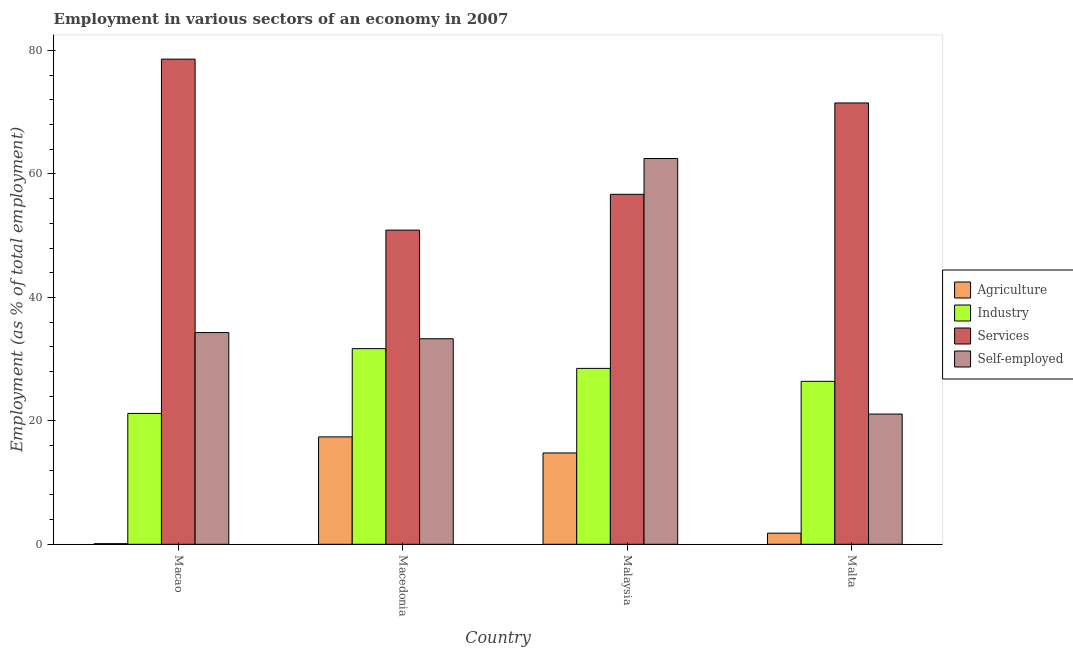How many groups of bars are there?
Offer a terse response. 4. How many bars are there on the 4th tick from the right?
Ensure brevity in your answer.  4. What is the label of the 2nd group of bars from the left?
Your answer should be very brief. Macedonia. In how many cases, is the number of bars for a given country not equal to the number of legend labels?
Your response must be concise. 0. What is the percentage of self employed workers in Malta?
Ensure brevity in your answer.  21.1. Across all countries, what is the maximum percentage of self employed workers?
Your response must be concise. 62.5. Across all countries, what is the minimum percentage of workers in services?
Provide a succinct answer. 50.9. In which country was the percentage of workers in services maximum?
Give a very brief answer. Macao. In which country was the percentage of workers in services minimum?
Ensure brevity in your answer.  Macedonia. What is the total percentage of workers in agriculture in the graph?
Provide a succinct answer. 34.1. What is the difference between the percentage of self employed workers in Macedonia and that in Malta?
Your answer should be very brief. 12.2. What is the difference between the percentage of workers in services in Malaysia and the percentage of workers in agriculture in Macedonia?
Provide a short and direct response. 39.3. What is the average percentage of workers in agriculture per country?
Your answer should be very brief. 8.52. What is the difference between the percentage of workers in agriculture and percentage of workers in services in Malaysia?
Offer a very short reply. -41.9. What is the ratio of the percentage of self employed workers in Macao to that in Macedonia?
Give a very brief answer. 1.03. Is the percentage of self employed workers in Macao less than that in Macedonia?
Offer a terse response. No. Is the difference between the percentage of workers in agriculture in Macao and Malaysia greater than the difference between the percentage of self employed workers in Macao and Malaysia?
Provide a succinct answer. Yes. What is the difference between the highest and the second highest percentage of workers in industry?
Give a very brief answer. 3.2. What is the difference between the highest and the lowest percentage of workers in services?
Give a very brief answer. 27.7. In how many countries, is the percentage of self employed workers greater than the average percentage of self employed workers taken over all countries?
Your answer should be compact. 1. Is it the case that in every country, the sum of the percentage of self employed workers and percentage of workers in agriculture is greater than the sum of percentage of workers in services and percentage of workers in industry?
Give a very brief answer. No. What does the 4th bar from the left in Malta represents?
Your response must be concise. Self-employed. What does the 2nd bar from the right in Macao represents?
Give a very brief answer. Services. Are all the bars in the graph horizontal?
Your response must be concise. No. How many countries are there in the graph?
Make the answer very short. 4. Are the values on the major ticks of Y-axis written in scientific E-notation?
Provide a short and direct response. No. Does the graph contain grids?
Your answer should be compact. No. How are the legend labels stacked?
Your response must be concise. Vertical. What is the title of the graph?
Ensure brevity in your answer.  Employment in various sectors of an economy in 2007. What is the label or title of the Y-axis?
Offer a terse response. Employment (as % of total employment). What is the Employment (as % of total employment) in Agriculture in Macao?
Offer a terse response. 0.1. What is the Employment (as % of total employment) of Industry in Macao?
Give a very brief answer. 21.2. What is the Employment (as % of total employment) of Services in Macao?
Provide a succinct answer. 78.6. What is the Employment (as % of total employment) in Self-employed in Macao?
Make the answer very short. 34.3. What is the Employment (as % of total employment) in Agriculture in Macedonia?
Give a very brief answer. 17.4. What is the Employment (as % of total employment) in Industry in Macedonia?
Keep it short and to the point. 31.7. What is the Employment (as % of total employment) in Services in Macedonia?
Your answer should be very brief. 50.9. What is the Employment (as % of total employment) of Self-employed in Macedonia?
Provide a succinct answer. 33.3. What is the Employment (as % of total employment) in Agriculture in Malaysia?
Provide a succinct answer. 14.8. What is the Employment (as % of total employment) of Industry in Malaysia?
Offer a very short reply. 28.5. What is the Employment (as % of total employment) of Services in Malaysia?
Keep it short and to the point. 56.7. What is the Employment (as % of total employment) of Self-employed in Malaysia?
Offer a very short reply. 62.5. What is the Employment (as % of total employment) of Agriculture in Malta?
Your answer should be very brief. 1.8. What is the Employment (as % of total employment) in Industry in Malta?
Make the answer very short. 26.4. What is the Employment (as % of total employment) in Services in Malta?
Make the answer very short. 71.5. What is the Employment (as % of total employment) in Self-employed in Malta?
Offer a terse response. 21.1. Across all countries, what is the maximum Employment (as % of total employment) of Agriculture?
Give a very brief answer. 17.4. Across all countries, what is the maximum Employment (as % of total employment) in Industry?
Your response must be concise. 31.7. Across all countries, what is the maximum Employment (as % of total employment) of Services?
Ensure brevity in your answer.  78.6. Across all countries, what is the maximum Employment (as % of total employment) of Self-employed?
Offer a terse response. 62.5. Across all countries, what is the minimum Employment (as % of total employment) of Agriculture?
Offer a very short reply. 0.1. Across all countries, what is the minimum Employment (as % of total employment) of Industry?
Offer a terse response. 21.2. Across all countries, what is the minimum Employment (as % of total employment) of Services?
Provide a succinct answer. 50.9. Across all countries, what is the minimum Employment (as % of total employment) of Self-employed?
Your answer should be very brief. 21.1. What is the total Employment (as % of total employment) of Agriculture in the graph?
Offer a very short reply. 34.1. What is the total Employment (as % of total employment) in Industry in the graph?
Your answer should be compact. 107.8. What is the total Employment (as % of total employment) of Services in the graph?
Give a very brief answer. 257.7. What is the total Employment (as % of total employment) in Self-employed in the graph?
Make the answer very short. 151.2. What is the difference between the Employment (as % of total employment) in Agriculture in Macao and that in Macedonia?
Your answer should be very brief. -17.3. What is the difference between the Employment (as % of total employment) of Services in Macao and that in Macedonia?
Offer a very short reply. 27.7. What is the difference between the Employment (as % of total employment) of Self-employed in Macao and that in Macedonia?
Provide a succinct answer. 1. What is the difference between the Employment (as % of total employment) in Agriculture in Macao and that in Malaysia?
Make the answer very short. -14.7. What is the difference between the Employment (as % of total employment) in Industry in Macao and that in Malaysia?
Offer a very short reply. -7.3. What is the difference between the Employment (as % of total employment) in Services in Macao and that in Malaysia?
Give a very brief answer. 21.9. What is the difference between the Employment (as % of total employment) of Self-employed in Macao and that in Malaysia?
Keep it short and to the point. -28.2. What is the difference between the Employment (as % of total employment) in Agriculture in Macao and that in Malta?
Your response must be concise. -1.7. What is the difference between the Employment (as % of total employment) of Services in Macao and that in Malta?
Provide a short and direct response. 7.1. What is the difference between the Employment (as % of total employment) in Self-employed in Macao and that in Malta?
Offer a very short reply. 13.2. What is the difference between the Employment (as % of total employment) in Self-employed in Macedonia and that in Malaysia?
Keep it short and to the point. -29.2. What is the difference between the Employment (as % of total employment) in Industry in Macedonia and that in Malta?
Offer a very short reply. 5.3. What is the difference between the Employment (as % of total employment) of Services in Macedonia and that in Malta?
Your answer should be very brief. -20.6. What is the difference between the Employment (as % of total employment) in Industry in Malaysia and that in Malta?
Keep it short and to the point. 2.1. What is the difference between the Employment (as % of total employment) in Services in Malaysia and that in Malta?
Provide a short and direct response. -14.8. What is the difference between the Employment (as % of total employment) of Self-employed in Malaysia and that in Malta?
Offer a very short reply. 41.4. What is the difference between the Employment (as % of total employment) of Agriculture in Macao and the Employment (as % of total employment) of Industry in Macedonia?
Provide a short and direct response. -31.6. What is the difference between the Employment (as % of total employment) in Agriculture in Macao and the Employment (as % of total employment) in Services in Macedonia?
Provide a succinct answer. -50.8. What is the difference between the Employment (as % of total employment) of Agriculture in Macao and the Employment (as % of total employment) of Self-employed in Macedonia?
Offer a very short reply. -33.2. What is the difference between the Employment (as % of total employment) of Industry in Macao and the Employment (as % of total employment) of Services in Macedonia?
Make the answer very short. -29.7. What is the difference between the Employment (as % of total employment) in Industry in Macao and the Employment (as % of total employment) in Self-employed in Macedonia?
Make the answer very short. -12.1. What is the difference between the Employment (as % of total employment) in Services in Macao and the Employment (as % of total employment) in Self-employed in Macedonia?
Offer a terse response. 45.3. What is the difference between the Employment (as % of total employment) in Agriculture in Macao and the Employment (as % of total employment) in Industry in Malaysia?
Give a very brief answer. -28.4. What is the difference between the Employment (as % of total employment) of Agriculture in Macao and the Employment (as % of total employment) of Services in Malaysia?
Provide a succinct answer. -56.6. What is the difference between the Employment (as % of total employment) of Agriculture in Macao and the Employment (as % of total employment) of Self-employed in Malaysia?
Provide a short and direct response. -62.4. What is the difference between the Employment (as % of total employment) in Industry in Macao and the Employment (as % of total employment) in Services in Malaysia?
Offer a terse response. -35.5. What is the difference between the Employment (as % of total employment) in Industry in Macao and the Employment (as % of total employment) in Self-employed in Malaysia?
Make the answer very short. -41.3. What is the difference between the Employment (as % of total employment) of Services in Macao and the Employment (as % of total employment) of Self-employed in Malaysia?
Make the answer very short. 16.1. What is the difference between the Employment (as % of total employment) of Agriculture in Macao and the Employment (as % of total employment) of Industry in Malta?
Offer a terse response. -26.3. What is the difference between the Employment (as % of total employment) of Agriculture in Macao and the Employment (as % of total employment) of Services in Malta?
Your answer should be compact. -71.4. What is the difference between the Employment (as % of total employment) in Agriculture in Macao and the Employment (as % of total employment) in Self-employed in Malta?
Give a very brief answer. -21. What is the difference between the Employment (as % of total employment) of Industry in Macao and the Employment (as % of total employment) of Services in Malta?
Your response must be concise. -50.3. What is the difference between the Employment (as % of total employment) of Services in Macao and the Employment (as % of total employment) of Self-employed in Malta?
Provide a succinct answer. 57.5. What is the difference between the Employment (as % of total employment) in Agriculture in Macedonia and the Employment (as % of total employment) in Industry in Malaysia?
Offer a very short reply. -11.1. What is the difference between the Employment (as % of total employment) of Agriculture in Macedonia and the Employment (as % of total employment) of Services in Malaysia?
Provide a short and direct response. -39.3. What is the difference between the Employment (as % of total employment) in Agriculture in Macedonia and the Employment (as % of total employment) in Self-employed in Malaysia?
Ensure brevity in your answer.  -45.1. What is the difference between the Employment (as % of total employment) in Industry in Macedonia and the Employment (as % of total employment) in Services in Malaysia?
Offer a terse response. -25. What is the difference between the Employment (as % of total employment) in Industry in Macedonia and the Employment (as % of total employment) in Self-employed in Malaysia?
Ensure brevity in your answer.  -30.8. What is the difference between the Employment (as % of total employment) in Agriculture in Macedonia and the Employment (as % of total employment) in Services in Malta?
Make the answer very short. -54.1. What is the difference between the Employment (as % of total employment) in Industry in Macedonia and the Employment (as % of total employment) in Services in Malta?
Make the answer very short. -39.8. What is the difference between the Employment (as % of total employment) in Industry in Macedonia and the Employment (as % of total employment) in Self-employed in Malta?
Give a very brief answer. 10.6. What is the difference between the Employment (as % of total employment) of Services in Macedonia and the Employment (as % of total employment) of Self-employed in Malta?
Make the answer very short. 29.8. What is the difference between the Employment (as % of total employment) in Agriculture in Malaysia and the Employment (as % of total employment) in Services in Malta?
Give a very brief answer. -56.7. What is the difference between the Employment (as % of total employment) of Agriculture in Malaysia and the Employment (as % of total employment) of Self-employed in Malta?
Provide a succinct answer. -6.3. What is the difference between the Employment (as % of total employment) of Industry in Malaysia and the Employment (as % of total employment) of Services in Malta?
Your response must be concise. -43. What is the difference between the Employment (as % of total employment) of Services in Malaysia and the Employment (as % of total employment) of Self-employed in Malta?
Provide a short and direct response. 35.6. What is the average Employment (as % of total employment) of Agriculture per country?
Your response must be concise. 8.53. What is the average Employment (as % of total employment) of Industry per country?
Offer a terse response. 26.95. What is the average Employment (as % of total employment) of Services per country?
Offer a very short reply. 64.42. What is the average Employment (as % of total employment) of Self-employed per country?
Your answer should be very brief. 37.8. What is the difference between the Employment (as % of total employment) in Agriculture and Employment (as % of total employment) in Industry in Macao?
Offer a terse response. -21.1. What is the difference between the Employment (as % of total employment) of Agriculture and Employment (as % of total employment) of Services in Macao?
Give a very brief answer. -78.5. What is the difference between the Employment (as % of total employment) in Agriculture and Employment (as % of total employment) in Self-employed in Macao?
Your response must be concise. -34.2. What is the difference between the Employment (as % of total employment) in Industry and Employment (as % of total employment) in Services in Macao?
Give a very brief answer. -57.4. What is the difference between the Employment (as % of total employment) of Industry and Employment (as % of total employment) of Self-employed in Macao?
Offer a terse response. -13.1. What is the difference between the Employment (as % of total employment) of Services and Employment (as % of total employment) of Self-employed in Macao?
Offer a terse response. 44.3. What is the difference between the Employment (as % of total employment) in Agriculture and Employment (as % of total employment) in Industry in Macedonia?
Keep it short and to the point. -14.3. What is the difference between the Employment (as % of total employment) in Agriculture and Employment (as % of total employment) in Services in Macedonia?
Your response must be concise. -33.5. What is the difference between the Employment (as % of total employment) in Agriculture and Employment (as % of total employment) in Self-employed in Macedonia?
Give a very brief answer. -15.9. What is the difference between the Employment (as % of total employment) of Industry and Employment (as % of total employment) of Services in Macedonia?
Offer a terse response. -19.2. What is the difference between the Employment (as % of total employment) of Industry and Employment (as % of total employment) of Self-employed in Macedonia?
Provide a short and direct response. -1.6. What is the difference between the Employment (as % of total employment) of Services and Employment (as % of total employment) of Self-employed in Macedonia?
Give a very brief answer. 17.6. What is the difference between the Employment (as % of total employment) in Agriculture and Employment (as % of total employment) in Industry in Malaysia?
Keep it short and to the point. -13.7. What is the difference between the Employment (as % of total employment) of Agriculture and Employment (as % of total employment) of Services in Malaysia?
Ensure brevity in your answer.  -41.9. What is the difference between the Employment (as % of total employment) of Agriculture and Employment (as % of total employment) of Self-employed in Malaysia?
Your answer should be compact. -47.7. What is the difference between the Employment (as % of total employment) in Industry and Employment (as % of total employment) in Services in Malaysia?
Your answer should be very brief. -28.2. What is the difference between the Employment (as % of total employment) in Industry and Employment (as % of total employment) in Self-employed in Malaysia?
Provide a short and direct response. -34. What is the difference between the Employment (as % of total employment) in Agriculture and Employment (as % of total employment) in Industry in Malta?
Provide a short and direct response. -24.6. What is the difference between the Employment (as % of total employment) of Agriculture and Employment (as % of total employment) of Services in Malta?
Make the answer very short. -69.7. What is the difference between the Employment (as % of total employment) in Agriculture and Employment (as % of total employment) in Self-employed in Malta?
Give a very brief answer. -19.3. What is the difference between the Employment (as % of total employment) in Industry and Employment (as % of total employment) in Services in Malta?
Provide a short and direct response. -45.1. What is the difference between the Employment (as % of total employment) of Industry and Employment (as % of total employment) of Self-employed in Malta?
Your answer should be very brief. 5.3. What is the difference between the Employment (as % of total employment) of Services and Employment (as % of total employment) of Self-employed in Malta?
Provide a short and direct response. 50.4. What is the ratio of the Employment (as % of total employment) of Agriculture in Macao to that in Macedonia?
Provide a short and direct response. 0.01. What is the ratio of the Employment (as % of total employment) of Industry in Macao to that in Macedonia?
Ensure brevity in your answer.  0.67. What is the ratio of the Employment (as % of total employment) of Services in Macao to that in Macedonia?
Your answer should be compact. 1.54. What is the ratio of the Employment (as % of total employment) of Agriculture in Macao to that in Malaysia?
Offer a very short reply. 0.01. What is the ratio of the Employment (as % of total employment) of Industry in Macao to that in Malaysia?
Give a very brief answer. 0.74. What is the ratio of the Employment (as % of total employment) of Services in Macao to that in Malaysia?
Your response must be concise. 1.39. What is the ratio of the Employment (as % of total employment) of Self-employed in Macao to that in Malaysia?
Provide a short and direct response. 0.55. What is the ratio of the Employment (as % of total employment) of Agriculture in Macao to that in Malta?
Your answer should be compact. 0.06. What is the ratio of the Employment (as % of total employment) of Industry in Macao to that in Malta?
Keep it short and to the point. 0.8. What is the ratio of the Employment (as % of total employment) in Services in Macao to that in Malta?
Make the answer very short. 1.1. What is the ratio of the Employment (as % of total employment) of Self-employed in Macao to that in Malta?
Keep it short and to the point. 1.63. What is the ratio of the Employment (as % of total employment) in Agriculture in Macedonia to that in Malaysia?
Your answer should be compact. 1.18. What is the ratio of the Employment (as % of total employment) in Industry in Macedonia to that in Malaysia?
Your answer should be compact. 1.11. What is the ratio of the Employment (as % of total employment) in Services in Macedonia to that in Malaysia?
Your response must be concise. 0.9. What is the ratio of the Employment (as % of total employment) of Self-employed in Macedonia to that in Malaysia?
Make the answer very short. 0.53. What is the ratio of the Employment (as % of total employment) in Agriculture in Macedonia to that in Malta?
Keep it short and to the point. 9.67. What is the ratio of the Employment (as % of total employment) of Industry in Macedonia to that in Malta?
Make the answer very short. 1.2. What is the ratio of the Employment (as % of total employment) of Services in Macedonia to that in Malta?
Ensure brevity in your answer.  0.71. What is the ratio of the Employment (as % of total employment) in Self-employed in Macedonia to that in Malta?
Keep it short and to the point. 1.58. What is the ratio of the Employment (as % of total employment) of Agriculture in Malaysia to that in Malta?
Offer a terse response. 8.22. What is the ratio of the Employment (as % of total employment) of Industry in Malaysia to that in Malta?
Your response must be concise. 1.08. What is the ratio of the Employment (as % of total employment) of Services in Malaysia to that in Malta?
Ensure brevity in your answer.  0.79. What is the ratio of the Employment (as % of total employment) of Self-employed in Malaysia to that in Malta?
Your response must be concise. 2.96. What is the difference between the highest and the second highest Employment (as % of total employment) in Agriculture?
Provide a succinct answer. 2.6. What is the difference between the highest and the second highest Employment (as % of total employment) in Industry?
Make the answer very short. 3.2. What is the difference between the highest and the second highest Employment (as % of total employment) in Services?
Ensure brevity in your answer.  7.1. What is the difference between the highest and the second highest Employment (as % of total employment) in Self-employed?
Provide a short and direct response. 28.2. What is the difference between the highest and the lowest Employment (as % of total employment) in Agriculture?
Make the answer very short. 17.3. What is the difference between the highest and the lowest Employment (as % of total employment) of Services?
Give a very brief answer. 27.7. What is the difference between the highest and the lowest Employment (as % of total employment) in Self-employed?
Make the answer very short. 41.4. 